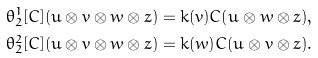Convert formula to latex. <formula><loc_0><loc_0><loc_500><loc_500>\theta _ { 2 } ^ { 1 } [ C ] ( u \otimes v \otimes w \otimes z ) = { k } ( v ) C ( u \otimes w \otimes z ) , \\ \theta _ { 2 } ^ { 2 } [ C ] ( u \otimes v \otimes w \otimes z ) = { k } ( w ) C ( u \otimes v \otimes z ) .</formula> 